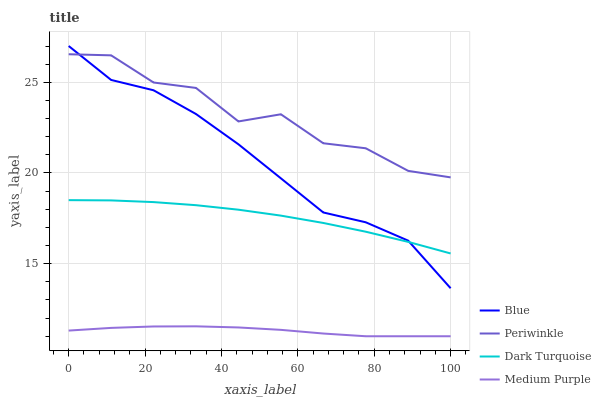Does Dark Turquoise have the minimum area under the curve?
Answer yes or no. No. Does Dark Turquoise have the maximum area under the curve?
Answer yes or no. No. Is Dark Turquoise the smoothest?
Answer yes or no. No. Is Dark Turquoise the roughest?
Answer yes or no. No. Does Dark Turquoise have the lowest value?
Answer yes or no. No. Does Dark Turquoise have the highest value?
Answer yes or no. No. Is Medium Purple less than Periwinkle?
Answer yes or no. Yes. Is Periwinkle greater than Medium Purple?
Answer yes or no. Yes. Does Medium Purple intersect Periwinkle?
Answer yes or no. No. 